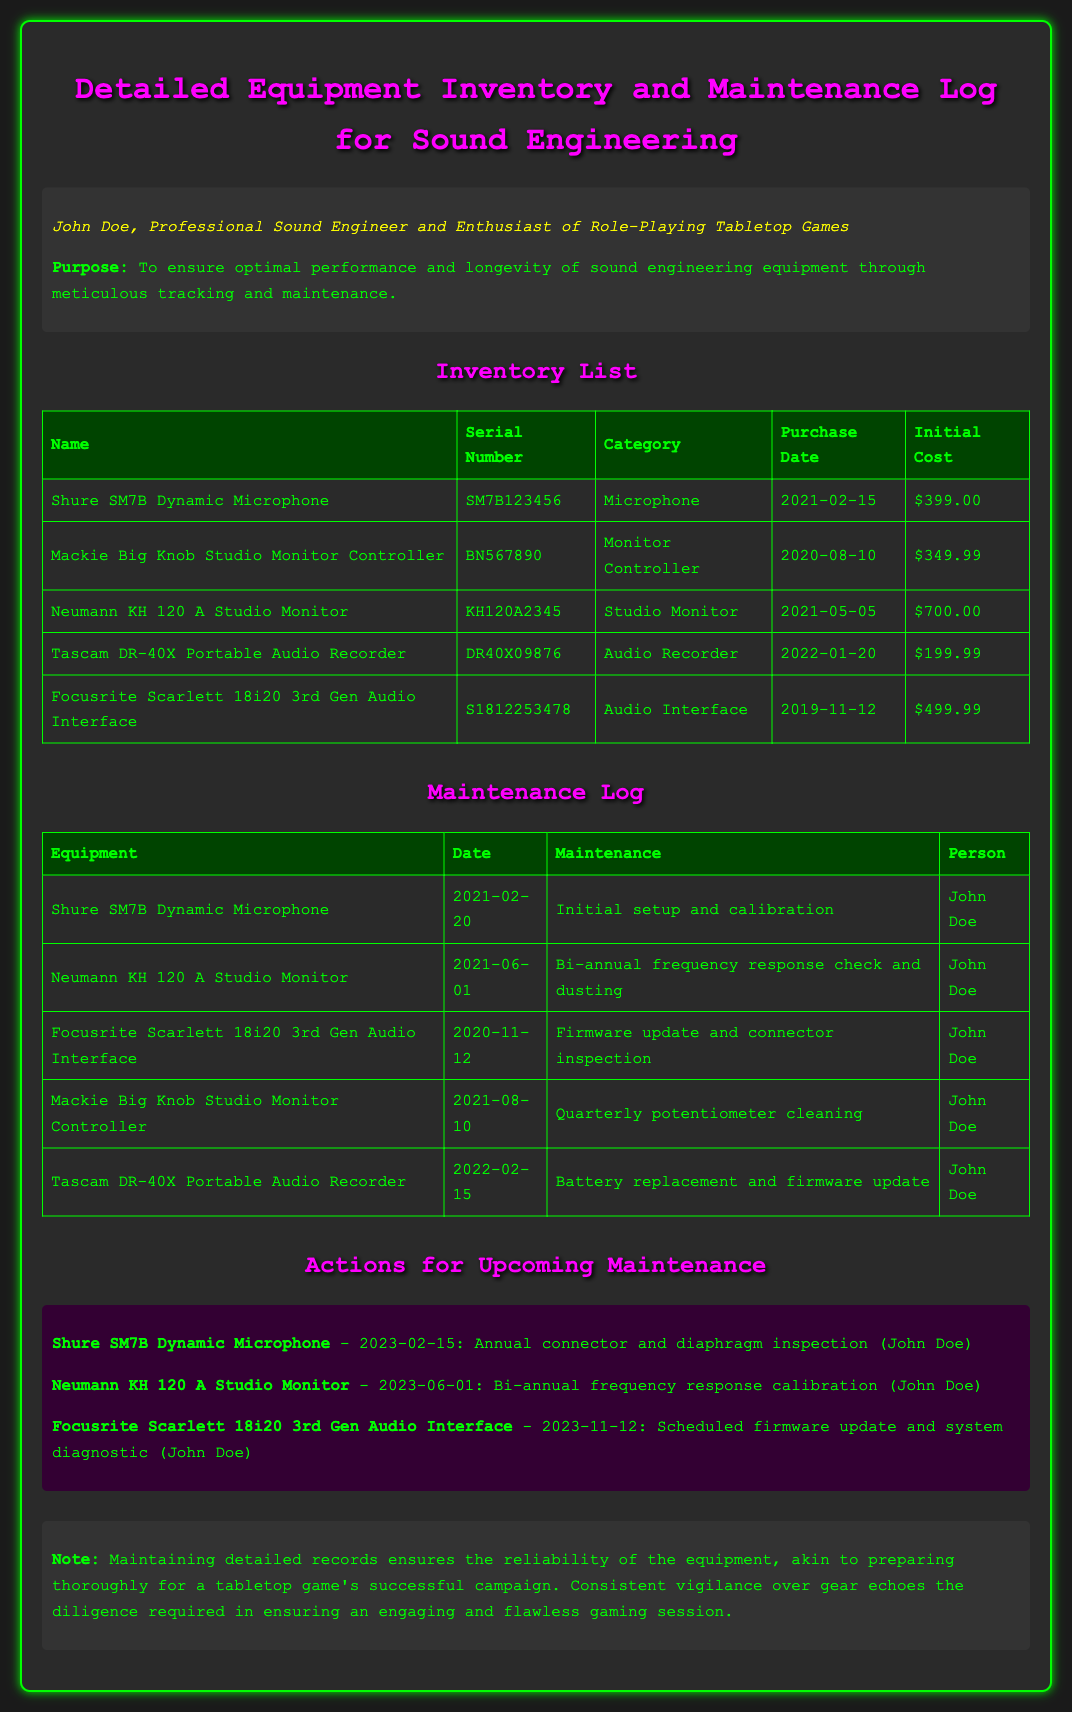What is the purpose of the document? The purpose is stated in the introduction as ensuring optimal performance and longevity of sound engineering equipment through meticulous tracking and maintenance.
Answer: To ensure optimal performance and longevity of sound engineering equipment through meticulous tracking and maintenance What is the category of the Shure SM7B Dynamic Microphone? The category of the equipment is specified in the inventory table.
Answer: Microphone When was the Neumann KH 120 A Studio Monitor purchased? The purchase date is indicated in the inventory table for this equipment.
Answer: 2021-05-05 Who performed the initial setup and calibration for the Shure SM7B? The person responsible for maintenance is listed in the maintenance log.
Answer: John Doe What maintenance is scheduled for the Focusrite Scarlett 18i20 on 2023-11-12? The upcoming maintenance describes the specific action to be taken that date.
Answer: Scheduled firmware update and system diagnostic How much did the Mackie Big Knob Studio Monitor Controller cost? The cost is shown in the inventory list for this equipment.
Answer: $349.99 What is the serial number of the Tascam DR-40X Portable Audio Recorder? The serial number is provided in the inventory table.
Answer: DR40X09876 What maintenance was performed on the Neumann KH 120 A Studio Monitor on 2021-06-01? The type of maintenance is specified in the maintenance log for that date.
Answer: Bi-annual frequency response check and dusting What color is the background of the document? The overall background color of the document is reflected in the style settings.
Answer: Dark gray 